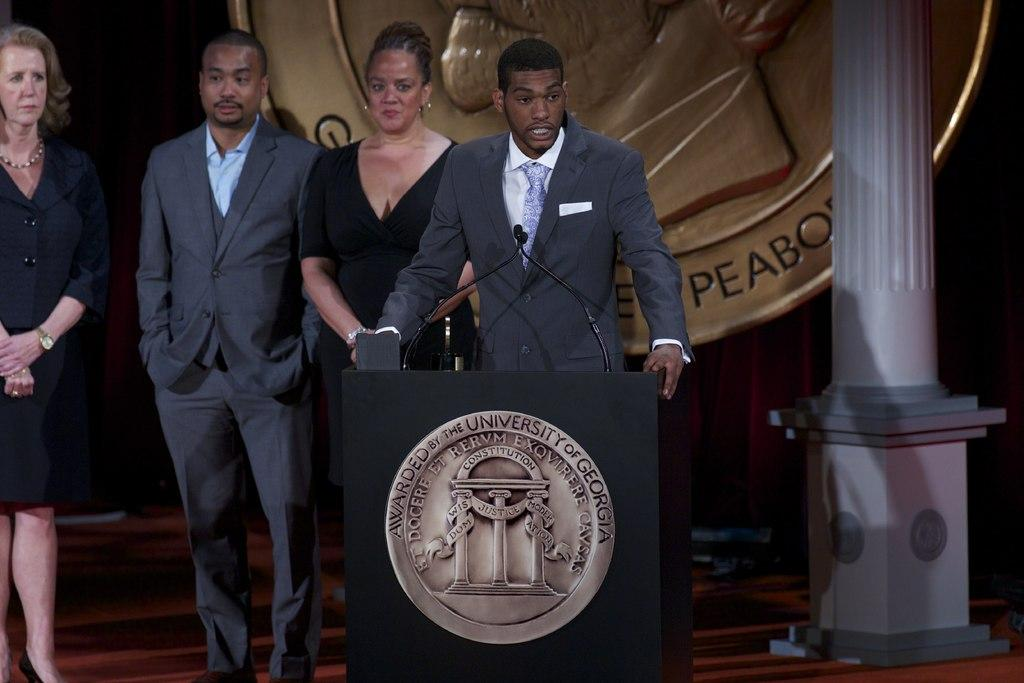<image>
Render a clear and concise summary of the photo. A man at a podium giving a speech with a sign behind him that has peabody on it. 